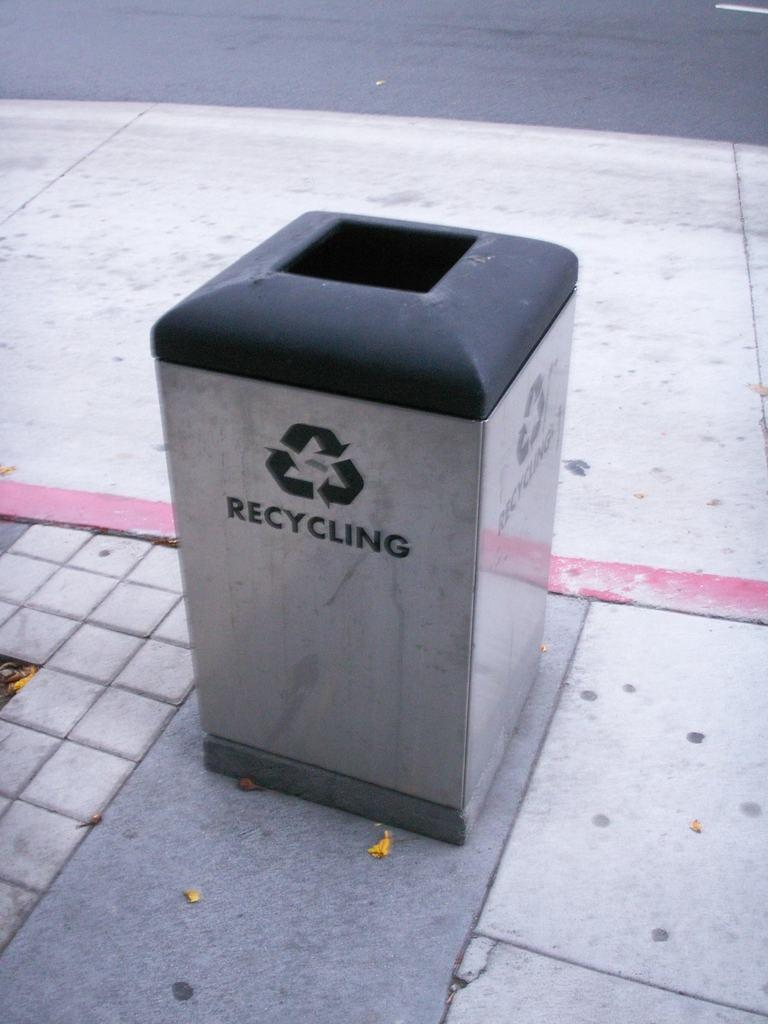<image>
Create a compact narrative representing the image presented. A recycling bin is sitting on a sidewalk. 